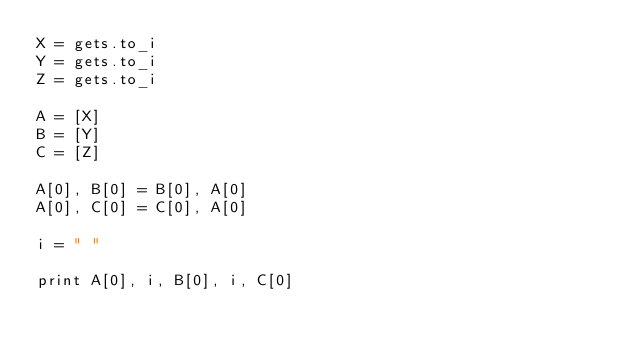Convert code to text. <code><loc_0><loc_0><loc_500><loc_500><_Ruby_>X = gets.to_i
Y = gets.to_i
Z = gets.to_i

A = [X]
B = [Y]
C = [Z]

A[0], B[0] = B[0], A[0]
A[0], C[0] = C[0], A[0]

i = " "

print A[0], i, B[0], i, C[0]</code> 